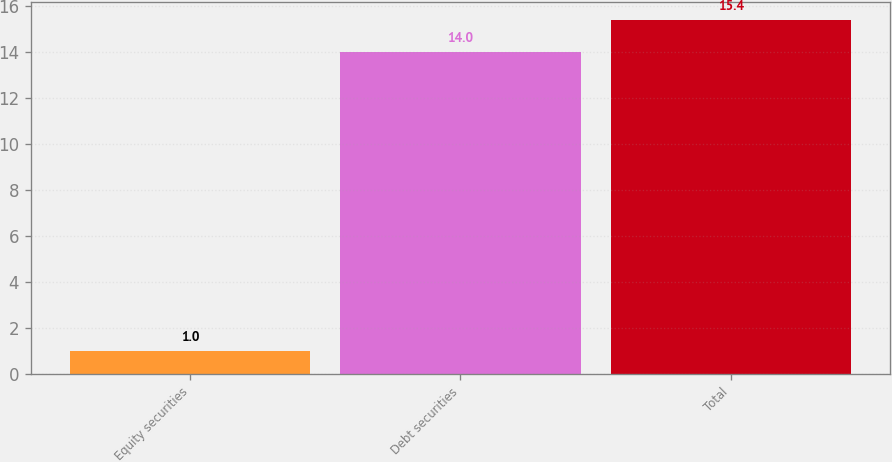Convert chart. <chart><loc_0><loc_0><loc_500><loc_500><bar_chart><fcel>Equity securities<fcel>Debt securities<fcel>Total<nl><fcel>1<fcel>14<fcel>15.4<nl></chart> 